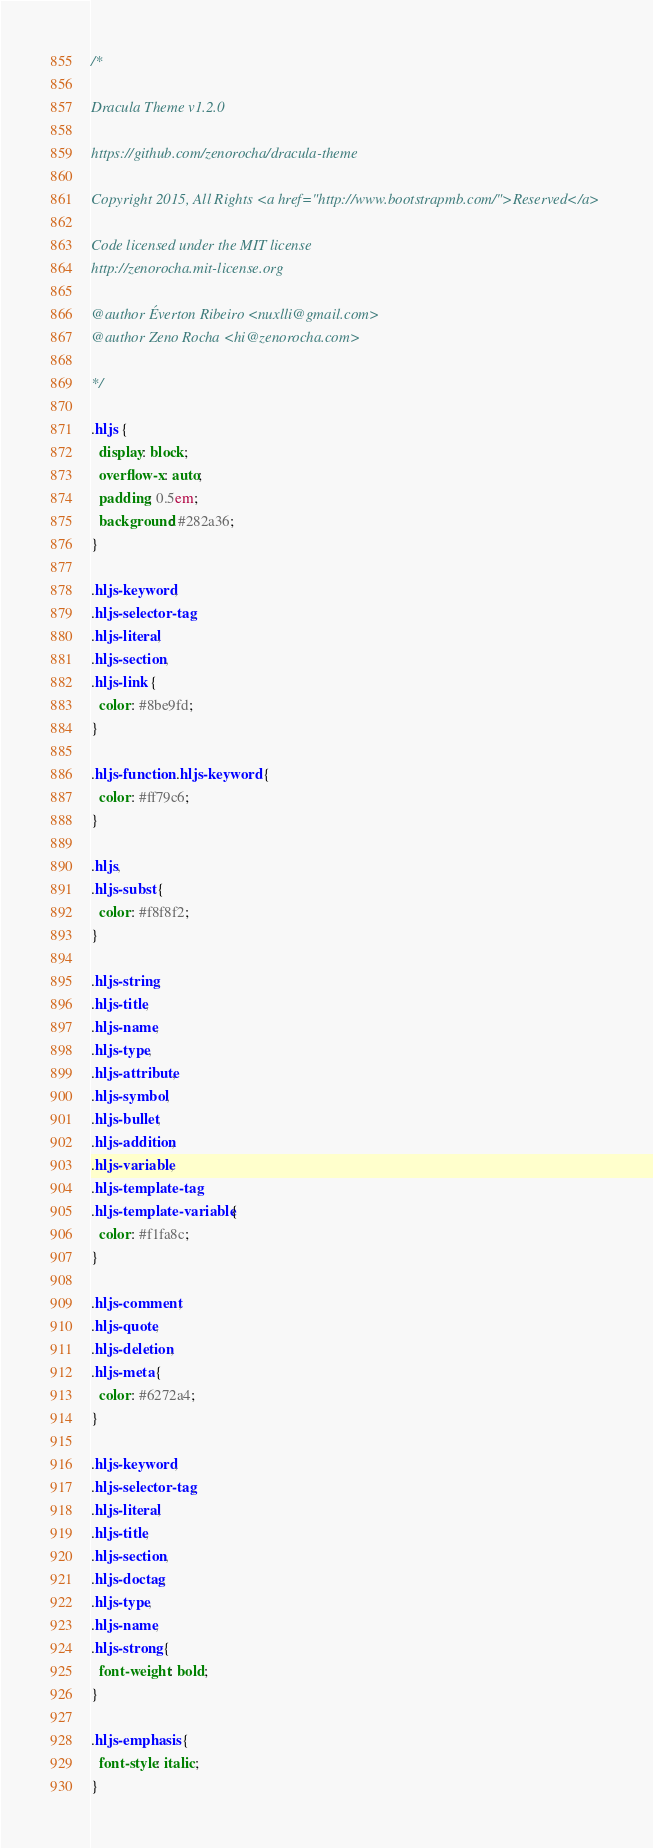<code> <loc_0><loc_0><loc_500><loc_500><_CSS_>/*

Dracula Theme v1.2.0

https://github.com/zenorocha/dracula-theme

Copyright 2015, All Rights <a href="http://www.bootstrapmb.com/">Reserved</a>

Code licensed under the MIT license
http://zenorocha.mit-license.org

@author Éverton Ribeiro <nuxlli@gmail.com>
@author Zeno Rocha <hi@zenorocha.com>

*/

.hljs {
  display: block;
  overflow-x: auto;
  padding: 0.5em;
  background: #282a36;
}

.hljs-keyword,
.hljs-selector-tag,
.hljs-literal,
.hljs-section,
.hljs-link {
  color: #8be9fd;
}

.hljs-function .hljs-keyword {
  color: #ff79c6;
}

.hljs,
.hljs-subst {
  color: #f8f8f2;
}

.hljs-string,
.hljs-title,
.hljs-name,
.hljs-type,
.hljs-attribute,
.hljs-symbol,
.hljs-bullet,
.hljs-addition,
.hljs-variable,
.hljs-template-tag,
.hljs-template-variable {
  color: #f1fa8c;
}

.hljs-comment,
.hljs-quote,
.hljs-deletion,
.hljs-meta {
  color: #6272a4;
}

.hljs-keyword,
.hljs-selector-tag,
.hljs-literal,
.hljs-title,
.hljs-section,
.hljs-doctag,
.hljs-type,
.hljs-name,
.hljs-strong {
  font-weight: bold;
}

.hljs-emphasis {
  font-style: italic;
}
</code> 